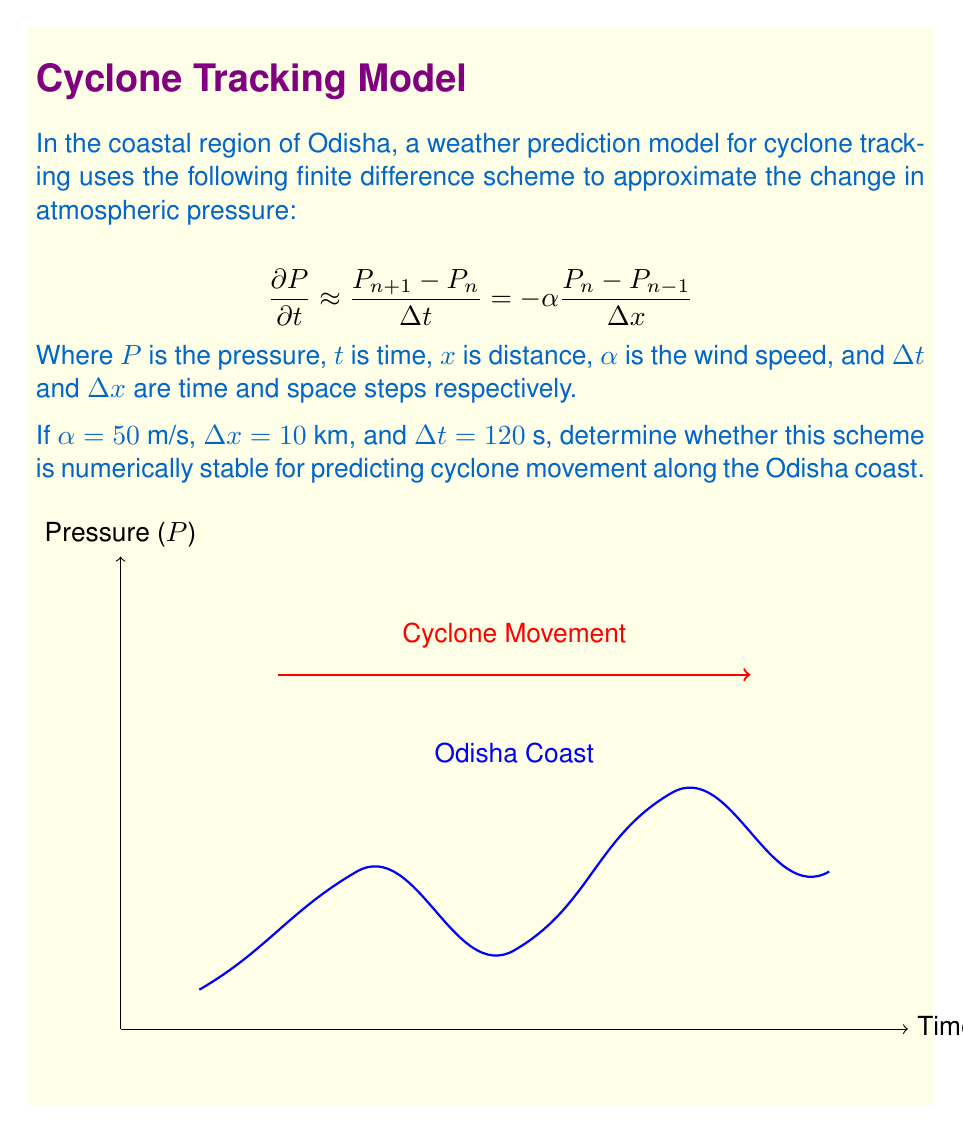Teach me how to tackle this problem. To analyze the numerical stability of this weather prediction model, we need to calculate the Courant-Friedrichs-Lewy (CFL) condition. The CFL condition is a necessary condition for convergence while solving certain partial differential equations numerically.

Step 1: Identify the CFL condition formula
For this type of finite difference scheme, the CFL condition is:

$$C = \frac{\alpha \Delta t}{\Delta x} \leq 1$$

Where $C$ is the Courant number.

Step 2: Calculate the Courant number
Given:
$\alpha = 50$ m/s
$\Delta t = 120$ s
$\Delta x = 10$ km = 10,000 m

Substituting these values into the CFL condition:

$$C = \frac{50 \text{ m/s} \times 120 \text{ s}}{10,000 \text{ m}} = 0.6$$

Step 3: Check stability
For the scheme to be numerically stable, we need $C \leq 1$.

In this case, $C = 0.6$, which is indeed less than or equal to 1.

Step 4: Interpret the result
Since the Courant number is less than 1, the finite difference scheme satisfies the CFL condition. This means the scheme is numerically stable for the given parameters.

It's important to note that while this condition is necessary for stability, it may not be sufficient in all cases. However, for simple advection equations like the one in this coastal weather prediction model, it is generally considered both necessary and sufficient.
Answer: The scheme is numerically stable (CFL condition satisfied: $C = 0.6 \leq 1$). 